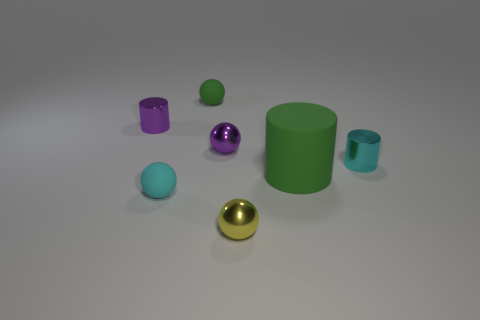What can you infer about the size of the objects in relation to each other? Analyzing the size of the objects relative to each other, we can infer that the big green cylinder is the largest object in the scene. The two cubes appear to be of the same size, possibly indicating that they function as a pair in this setting. The spheres vary in size with the gold one being the smallest, hinting at a deliberate gradation or size hierarchy among the round objects. Such an arrangement could suggest an underlying theme or purpose, possibly an aesthetic one or a visualization of data or concepts represented by size.  Do the positions of the objects suggest any specific pattern or arrangement? While there is no immediately discernible precise pattern in the placement of the objects, their dispersal across the plane could represent a random arrangement, a deliberate composition to portray contrast in colors and shapes, or an abstract representation with each object’s position holding a specific meaning. The open space around the objects may suggest a focus on individual characteristics or an intention to create a clean and simple visual field that directs attention to the differences in color, texture, and size among the objects. 